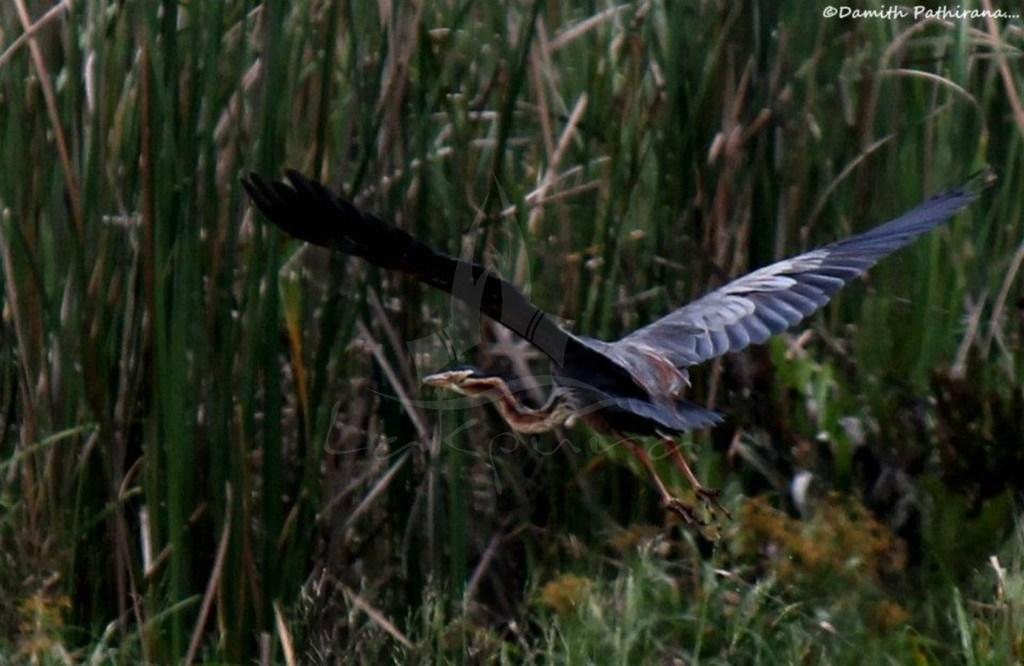What is the main subject of the image? The main subject of the image is a bird flying. What can be seen in the background of the image? There is grass visible in the background of the image. What type of potato can be seen growing in the image? There is no potato present in the image; it features a bird flying and grass in the background. How many ears can be seen on the bird in the image? Birds do not have ears like humans, and there is no indication of ears in the image. 